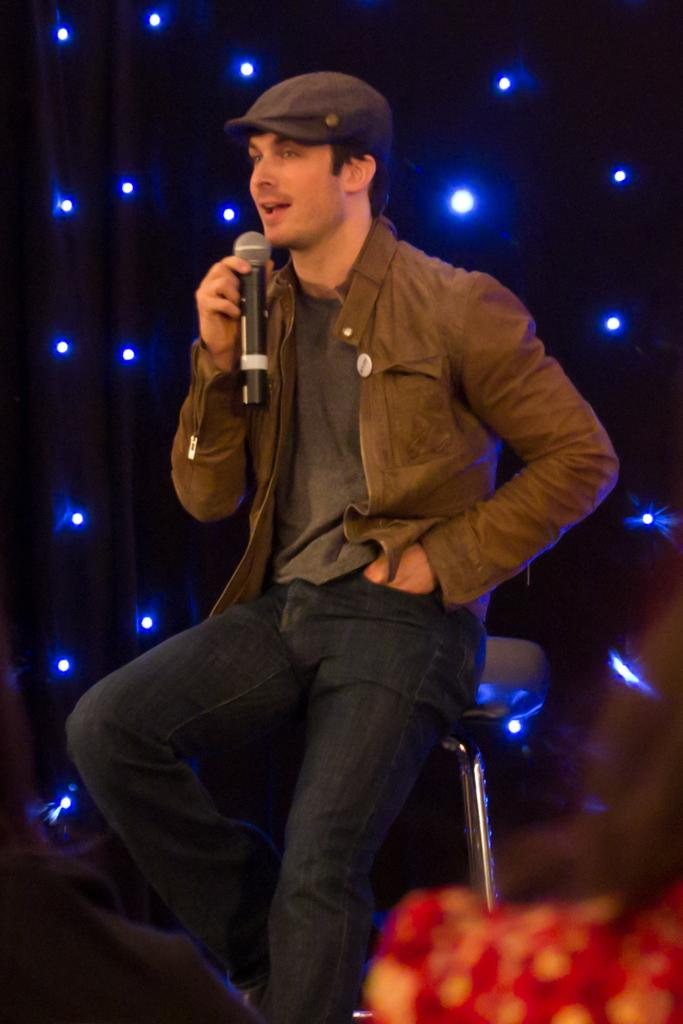Who is the main subject in the image? There is a man in the image. What is the man doing in the image? The man is sitting on a chair and appears to be singing. What object is the man holding in the image? The man is holding a microphone. What can be seen in the background of the image? There is a curtain and lights in the background of the image. What type of science experiment is the man conducting in the image? There is no science experiment present in the image; the man is singing while holding a microphone. How does the man say good-bye to the audience in the image? The image does not show the man saying good-bye to the audience, as it only captures him singing with a microphone. 